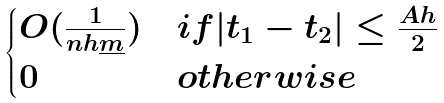Convert formula to latex. <formula><loc_0><loc_0><loc_500><loc_500>\begin{cases} O ( \frac { 1 } { n h \underline { m } } ) & i f | t _ { 1 } - t _ { 2 } | \leq \frac { A h } { 2 } \\ 0 & o t h e r w i s e \end{cases}</formula> 